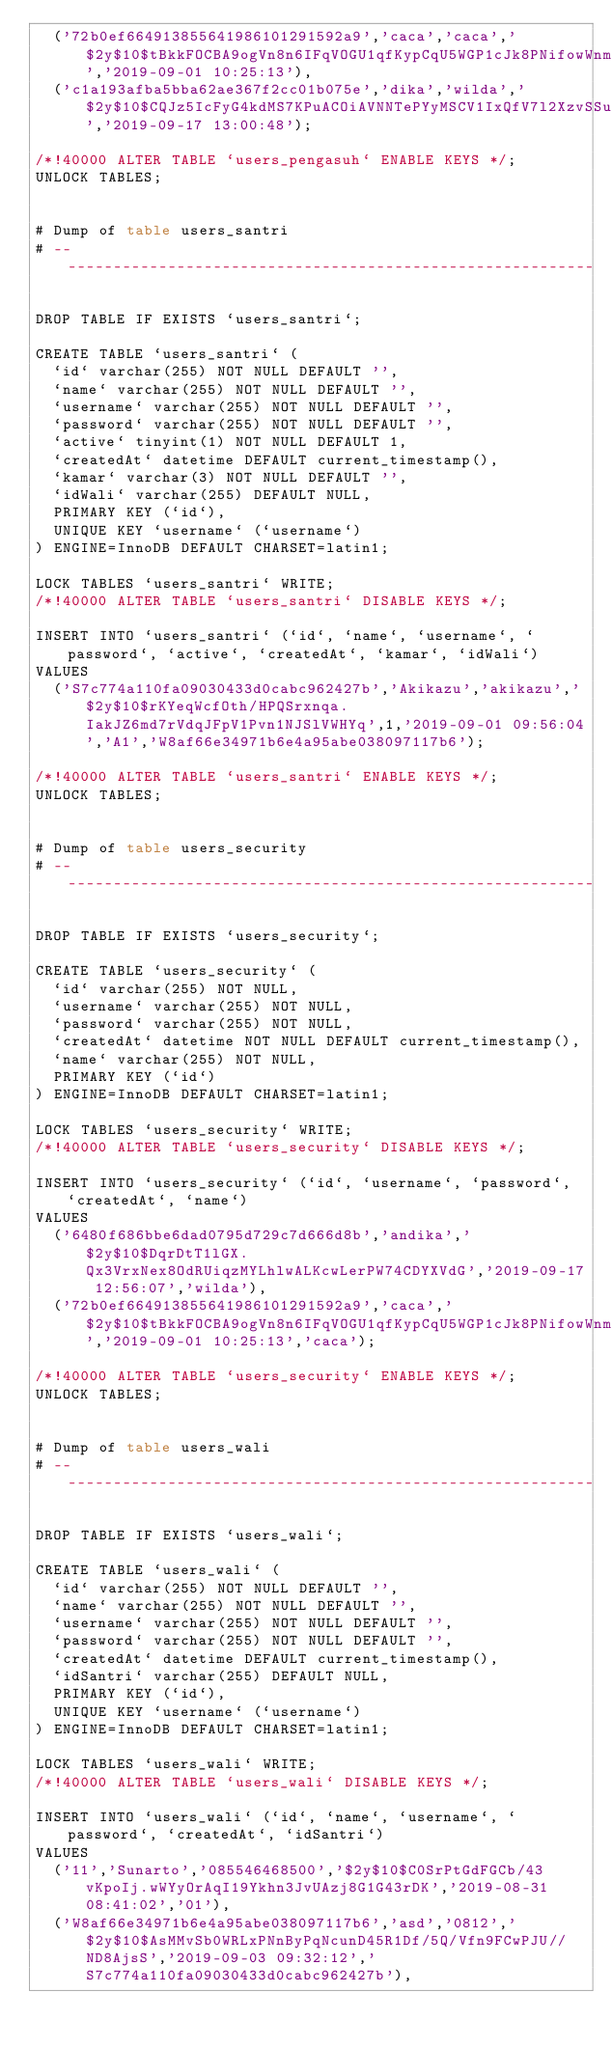<code> <loc_0><loc_0><loc_500><loc_500><_SQL_>	('72b0ef664913855641986101291592a9','caca','caca','$2y$10$tBkkFOCBA9ogVn8n6IFqVOGU1qfKypCqU5WGP1cJk8PNifowWnmWa','2019-09-01 10:25:13'),
	('c1a193afba5bba62ae367f2cc01b075e','dika','wilda','$2y$10$CQJz5IcFyG4kdMS7KPuACOiAVNNTePYyMSCV1IxQfV7l2XzvSSuOu','2019-09-17 13:00:48');

/*!40000 ALTER TABLE `users_pengasuh` ENABLE KEYS */;
UNLOCK TABLES;


# Dump of table users_santri
# ------------------------------------------------------------

DROP TABLE IF EXISTS `users_santri`;

CREATE TABLE `users_santri` (
  `id` varchar(255) NOT NULL DEFAULT '',
  `name` varchar(255) NOT NULL DEFAULT '',
  `username` varchar(255) NOT NULL DEFAULT '',
  `password` varchar(255) NOT NULL DEFAULT '',
  `active` tinyint(1) NOT NULL DEFAULT 1,
  `createdAt` datetime DEFAULT current_timestamp(),
  `kamar` varchar(3) NOT NULL DEFAULT '',
  `idWali` varchar(255) DEFAULT NULL,
  PRIMARY KEY (`id`),
  UNIQUE KEY `username` (`username`)
) ENGINE=InnoDB DEFAULT CHARSET=latin1;

LOCK TABLES `users_santri` WRITE;
/*!40000 ALTER TABLE `users_santri` DISABLE KEYS */;

INSERT INTO `users_santri` (`id`, `name`, `username`, `password`, `active`, `createdAt`, `kamar`, `idWali`)
VALUES
	('S7c774a110fa09030433d0cabc962427b','Akikazu','akikazu','$2y$10$rKYeqWcfOth/HPQSrxnqa.IakJZ6md7rVdqJFpV1Pvn1NJSlVWHYq',1,'2019-09-01 09:56:04','A1','W8af66e34971b6e4a95abe038097117b6');

/*!40000 ALTER TABLE `users_santri` ENABLE KEYS */;
UNLOCK TABLES;


# Dump of table users_security
# ------------------------------------------------------------

DROP TABLE IF EXISTS `users_security`;

CREATE TABLE `users_security` (
  `id` varchar(255) NOT NULL,
  `username` varchar(255) NOT NULL,
  `password` varchar(255) NOT NULL,
  `createdAt` datetime NOT NULL DEFAULT current_timestamp(),
  `name` varchar(255) NOT NULL,
  PRIMARY KEY (`id`)
) ENGINE=InnoDB DEFAULT CHARSET=latin1;

LOCK TABLES `users_security` WRITE;
/*!40000 ALTER TABLE `users_security` DISABLE KEYS */;

INSERT INTO `users_security` (`id`, `username`, `password`, `createdAt`, `name`)
VALUES
	('6480f686bbe6dad0795d729c7d666d8b','andika','$2y$10$DqrDtT1lGX.Qx3VrxNex8OdRUiqzMYLhlwALKcwLerPW74CDYXVdG','2019-09-17 12:56:07','wilda'),
	('72b0ef664913855641986101291592a9','caca','$2y$10$tBkkFOCBA9ogVn8n6IFqVOGU1qfKypCqU5WGP1cJk8PNifowWnmWa','2019-09-01 10:25:13','caca');

/*!40000 ALTER TABLE `users_security` ENABLE KEYS */;
UNLOCK TABLES;


# Dump of table users_wali
# ------------------------------------------------------------

DROP TABLE IF EXISTS `users_wali`;

CREATE TABLE `users_wali` (
  `id` varchar(255) NOT NULL DEFAULT '',
  `name` varchar(255) NOT NULL DEFAULT '',
  `username` varchar(255) NOT NULL DEFAULT '',
  `password` varchar(255) NOT NULL DEFAULT '',
  `createdAt` datetime DEFAULT current_timestamp(),
  `idSantri` varchar(255) DEFAULT NULL,
  PRIMARY KEY (`id`),
  UNIQUE KEY `username` (`username`)
) ENGINE=InnoDB DEFAULT CHARSET=latin1;

LOCK TABLES `users_wali` WRITE;
/*!40000 ALTER TABLE `users_wali` DISABLE KEYS */;

INSERT INTO `users_wali` (`id`, `name`, `username`, `password`, `createdAt`, `idSantri`)
VALUES
	('11','Sunarto','085546468500','$2y$10$C0SrPtGdFGCb/43vKpoIj.wWYyOrAqI19Ykhn3JvUAzj8G1G43rDK','2019-08-31 08:41:02','01'),
	('W8af66e34971b6e4a95abe038097117b6','asd','0812','$2y$10$AsMMvSb0WRLxPNnByPqNcunD45R1Df/5Q/Vfn9FCwPJU//ND8AjsS','2019-09-03 09:32:12','S7c774a110fa09030433d0cabc962427b'),</code> 